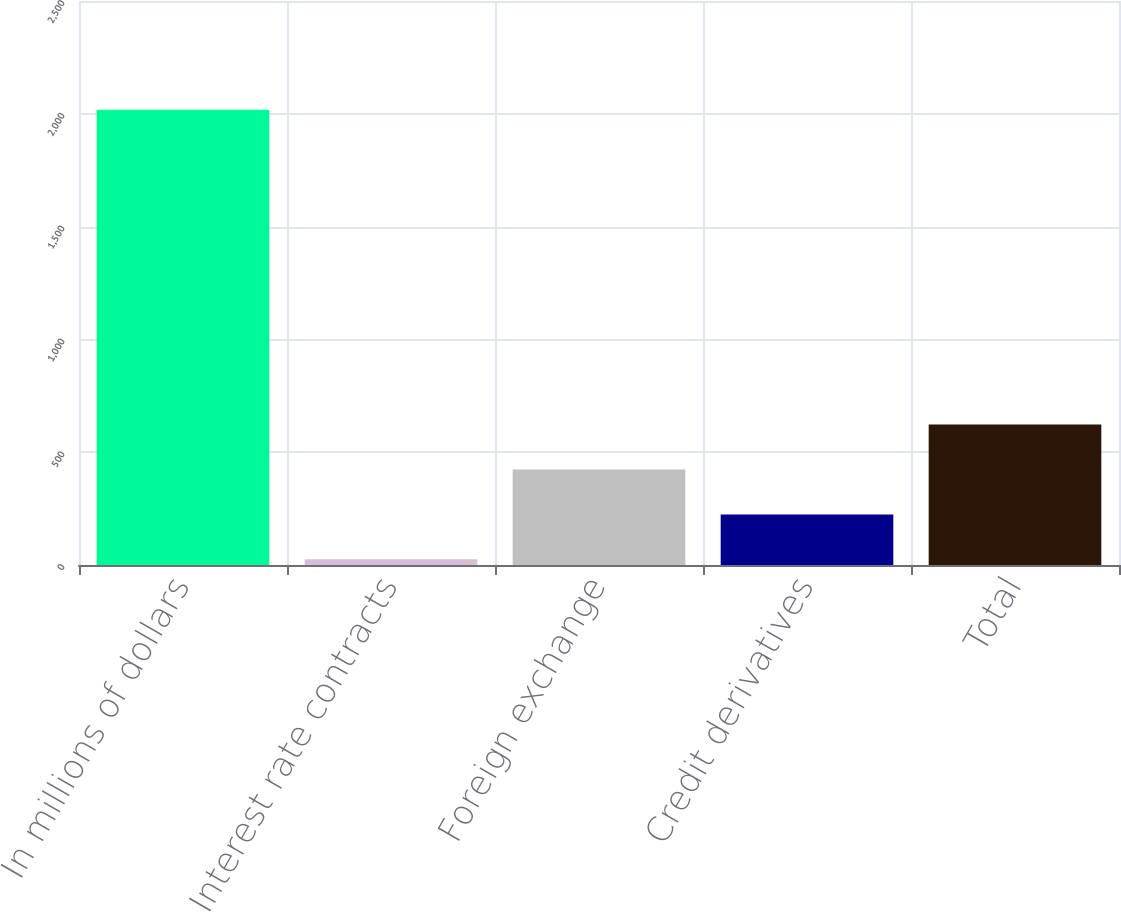Convert chart. <chart><loc_0><loc_0><loc_500><loc_500><bar_chart><fcel>In millions of dollars<fcel>Interest rate contracts<fcel>Foreign exchange<fcel>Credit derivatives<fcel>Total<nl><fcel>2018<fcel>25<fcel>423.6<fcel>224.3<fcel>622.9<nl></chart> 